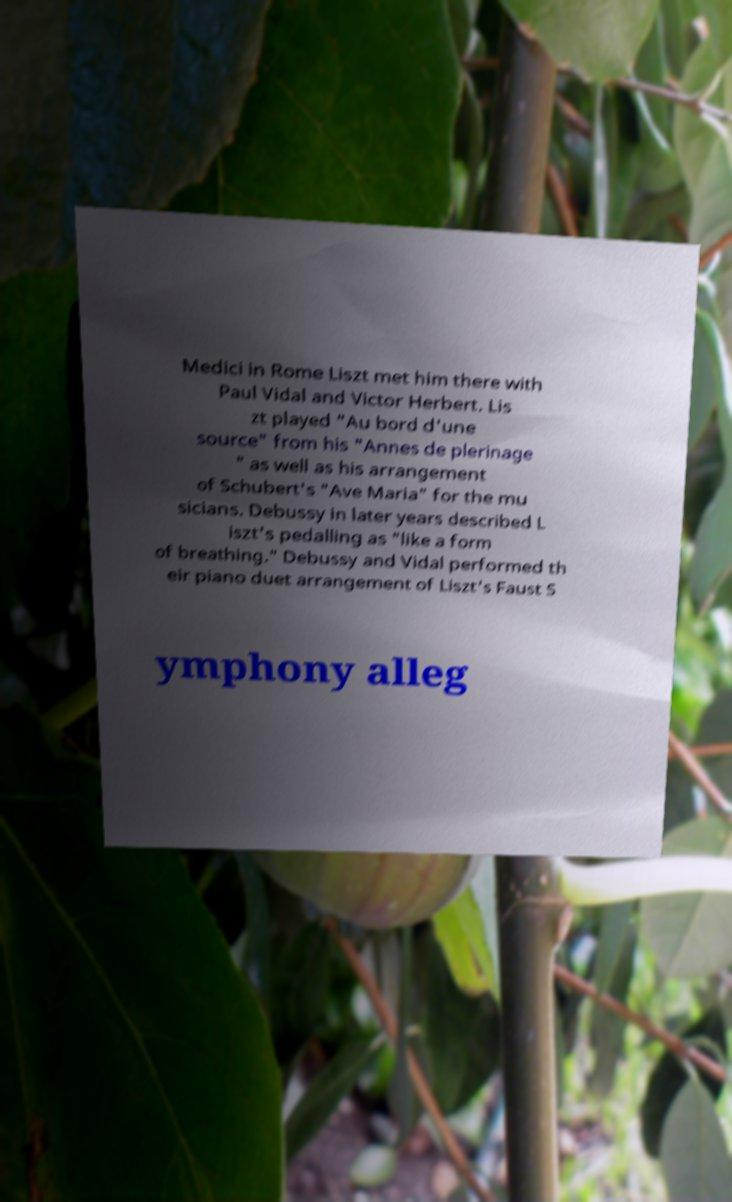I need the written content from this picture converted into text. Can you do that? Medici in Rome Liszt met him there with Paul Vidal and Victor Herbert. Lis zt played "Au bord d'une source" from his "Annes de plerinage " as well as his arrangement of Schubert's "Ave Maria" for the mu sicians. Debussy in later years described L iszt's pedalling as "like a form of breathing." Debussy and Vidal performed th eir piano duet arrangement of Liszt's Faust S ymphony alleg 